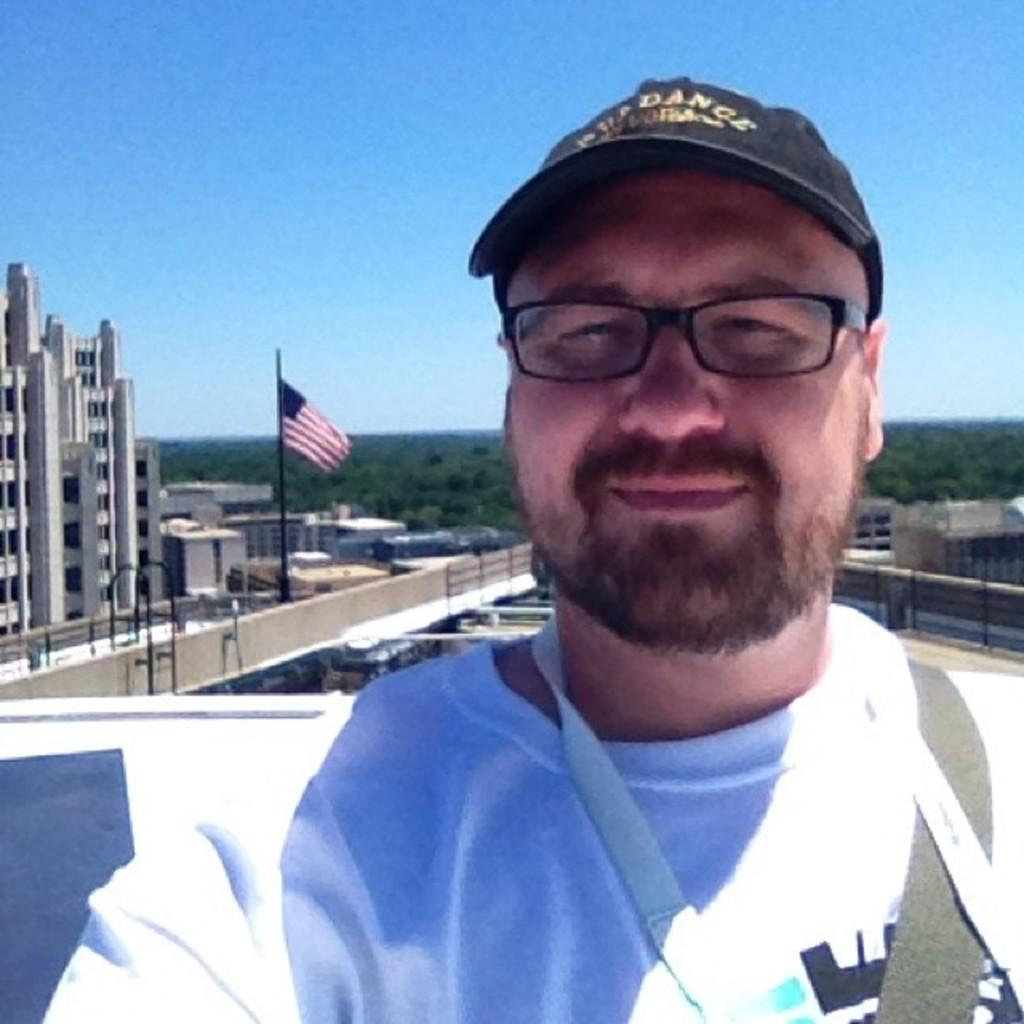What can be seen in the image? There is a person in the image. Can you describe the person's appearance? The person is wearing a cap and spectacles. What is visible at the back of the person? There is a flag visible at the back of the person. What can be seen in the background of the image? There are buildings, trees, some objects, and the sky visible in the background of the image. What theory does the person in the image have about the army? There is no indication in the image that the person has a theory about the army, as the image does not show any army-related context. 